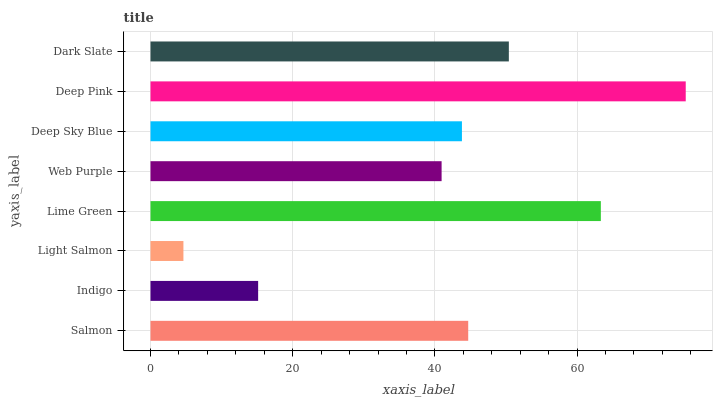Is Light Salmon the minimum?
Answer yes or no. Yes. Is Deep Pink the maximum?
Answer yes or no. Yes. Is Indigo the minimum?
Answer yes or no. No. Is Indigo the maximum?
Answer yes or no. No. Is Salmon greater than Indigo?
Answer yes or no. Yes. Is Indigo less than Salmon?
Answer yes or no. Yes. Is Indigo greater than Salmon?
Answer yes or no. No. Is Salmon less than Indigo?
Answer yes or no. No. Is Salmon the high median?
Answer yes or no. Yes. Is Deep Sky Blue the low median?
Answer yes or no. Yes. Is Deep Pink the high median?
Answer yes or no. No. Is Lime Green the low median?
Answer yes or no. No. 